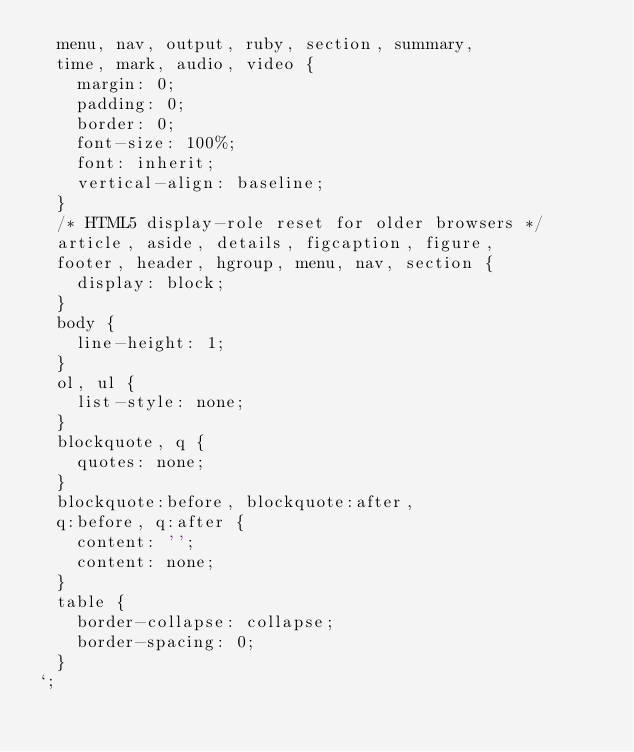<code> <loc_0><loc_0><loc_500><loc_500><_JavaScript_>  menu, nav, output, ruby, section, summary,
  time, mark, audio, video {
    margin: 0;
    padding: 0;
    border: 0;
    font-size: 100%;
    font: inherit;
    vertical-align: baseline;
  }
  /* HTML5 display-role reset for older browsers */
  article, aside, details, figcaption, figure, 
  footer, header, hgroup, menu, nav, section {
    display: block;
  }
  body {
    line-height: 1;
  }
  ol, ul {
    list-style: none;
  }
  blockquote, q {
    quotes: none;
  }
  blockquote:before, blockquote:after,
  q:before, q:after {
    content: '';
    content: none;
  }
  table {
    border-collapse: collapse;
    border-spacing: 0;
  }
`;</code> 